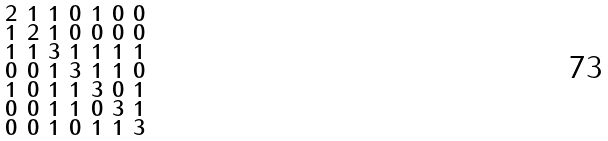Convert formula to latex. <formula><loc_0><loc_0><loc_500><loc_500>\begin{smallmatrix} 2 & 1 & 1 & 0 & 1 & 0 & 0 \\ 1 & 2 & 1 & 0 & 0 & 0 & 0 \\ 1 & 1 & 3 & 1 & 1 & 1 & 1 \\ 0 & 0 & 1 & 3 & 1 & 1 & 0 \\ 1 & 0 & 1 & 1 & 3 & 0 & 1 \\ 0 & 0 & 1 & 1 & 0 & 3 & 1 \\ 0 & 0 & 1 & 0 & 1 & 1 & 3 \end{smallmatrix}</formula> 